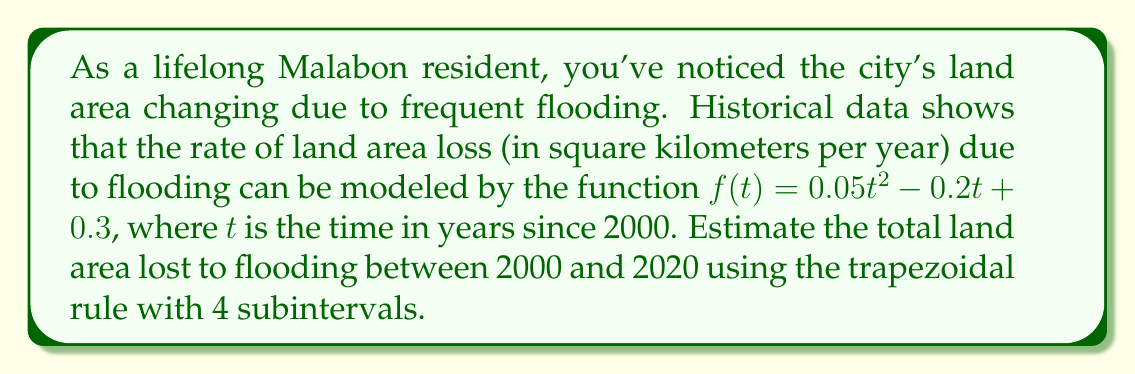Show me your answer to this math problem. To solve this problem, we'll use the trapezoidal rule for numerical integration. The steps are as follows:

1) The trapezoidal rule for n subintervals is given by:

   $$\int_{a}^{b} f(x) dx \approx \frac{b-a}{2n} [f(a) + 2f(x_1) + 2f(x_2) + ... + 2f(x_{n-1}) + f(b)]$$

2) In our case:
   - $a = 0$ (year 2000)
   - $b = 20$ (year 2020)
   - $n = 4$ (number of subintervals)

3) We need to calculate $f(t)$ at $t = 0, 5, 10, 15, 20$:

   $f(0) = 0.05(0)^2 - 0.2(0) + 0.3 = 0.3$
   $f(5) = 0.05(5)^2 - 0.2(5) + 0.3 = 0.55$
   $f(10) = 0.05(10)^2 - 0.2(10) + 0.3 = 2.3$
   $f(15) = 0.05(15)^2 - 0.2(15) + 0.3 = 5.55$
   $f(20) = 0.05(20)^2 - 0.2(20) + 0.3 = 10.3$

4) Applying the trapezoidal rule:

   $$\int_{0}^{20} f(t) dt \approx \frac{20-0}{2(4)} [f(0) + 2f(5) + 2f(10) + 2f(15) + f(20)]$$
   
   $$= \frac{20}{8} [0.3 + 2(0.55) + 2(2.3) + 2(5.55) + 10.3]$$
   
   $$= 2.5 [0.3 + 1.1 + 4.6 + 11.1 + 10.3]$$
   
   $$= 2.5 [27.4] = 68.5$$

Therefore, the estimated total land area lost to flooding between 2000 and 2020 is approximately 68.5 square kilometers.
Answer: 68.5 square kilometers 